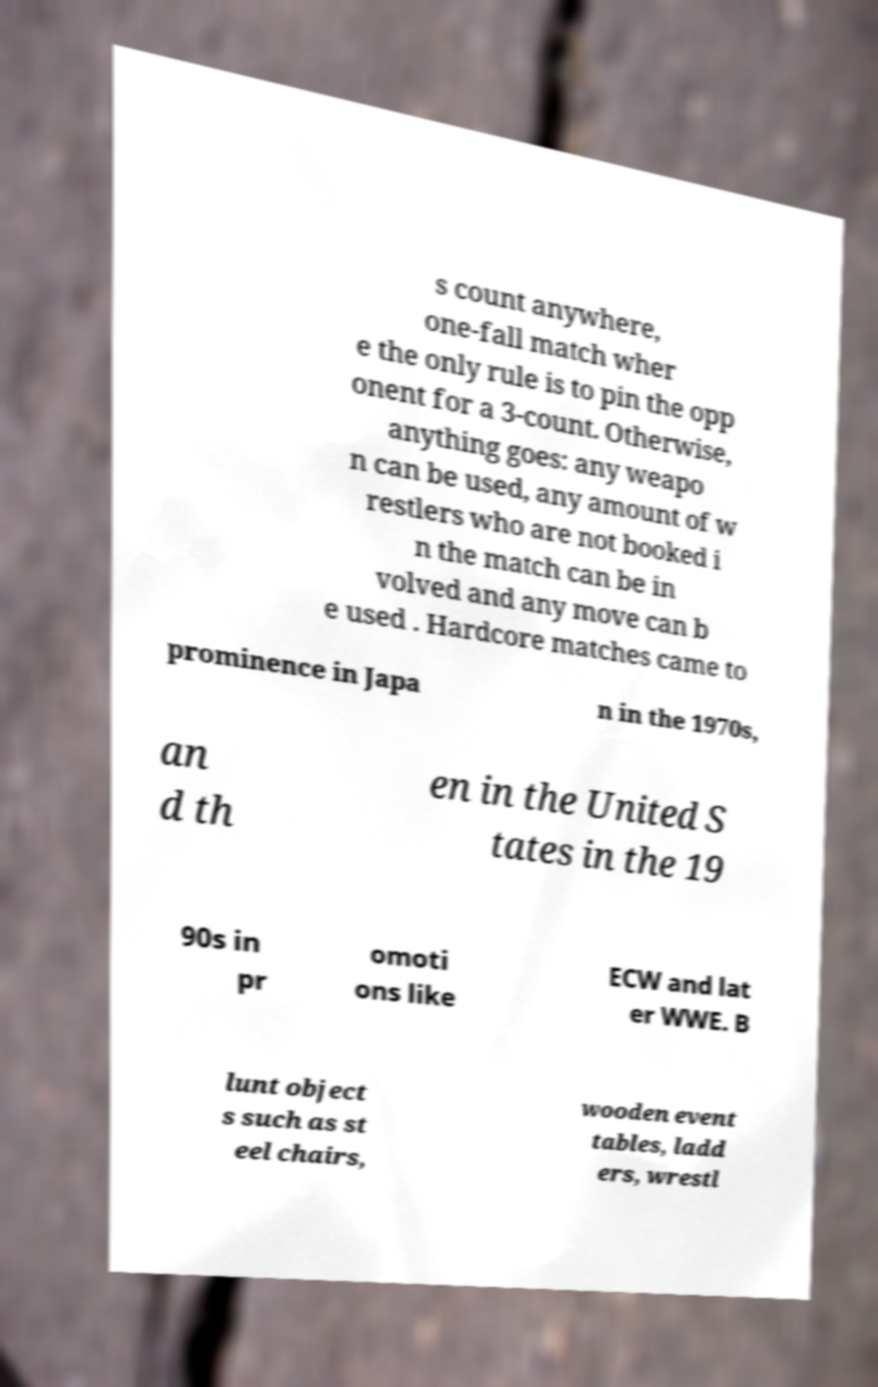Please read and relay the text visible in this image. What does it say? s count anywhere, one-fall match wher e the only rule is to pin the opp onent for a 3-count. Otherwise, anything goes: any weapo n can be used, any amount of w restlers who are not booked i n the match can be in volved and any move can b e used . Hardcore matches came to prominence in Japa n in the 1970s, an d th en in the United S tates in the 19 90s in pr omoti ons like ECW and lat er WWE. B lunt object s such as st eel chairs, wooden event tables, ladd ers, wrestl 